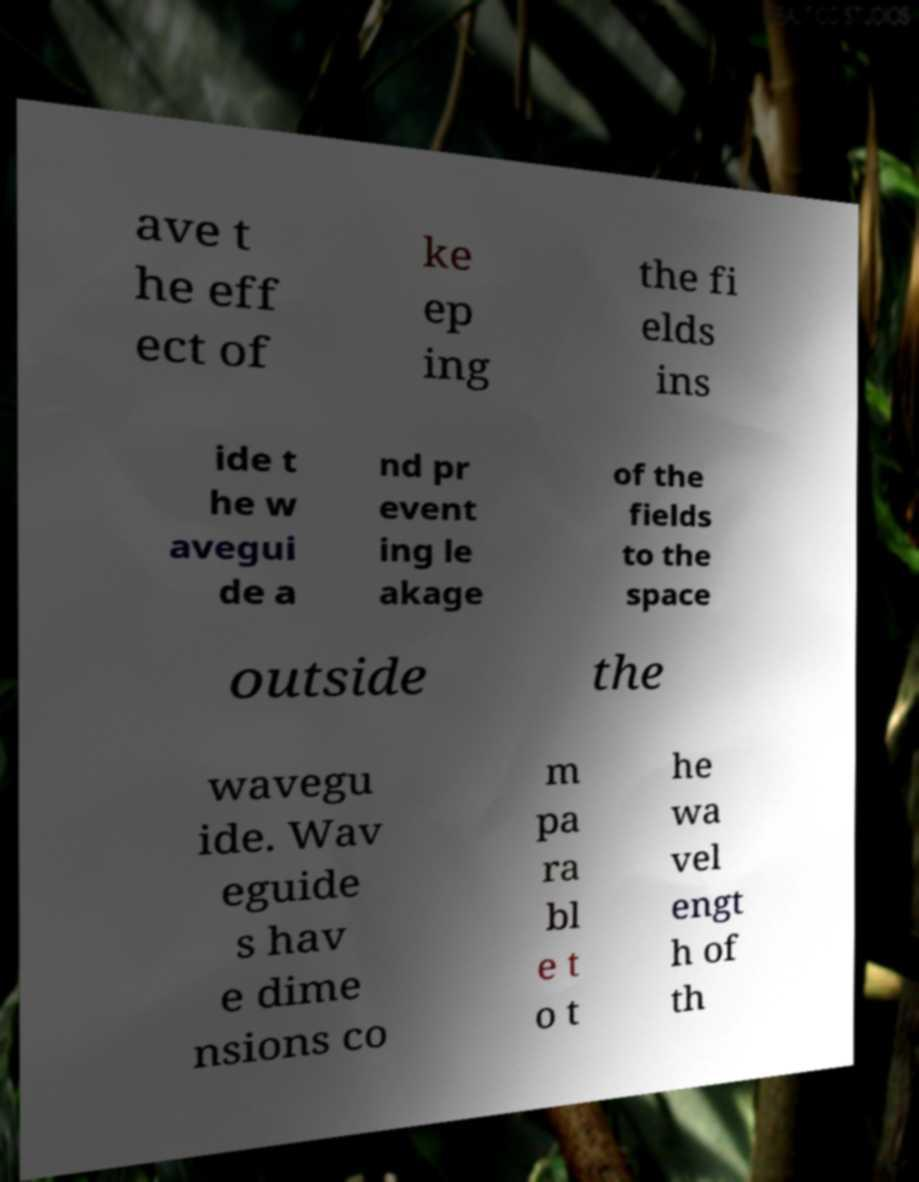What messages or text are displayed in this image? I need them in a readable, typed format. ave t he eff ect of ke ep ing the fi elds ins ide t he w avegui de a nd pr event ing le akage of the fields to the space outside the wavegu ide. Wav eguide s hav e dime nsions co m pa ra bl e t o t he wa vel engt h of th 